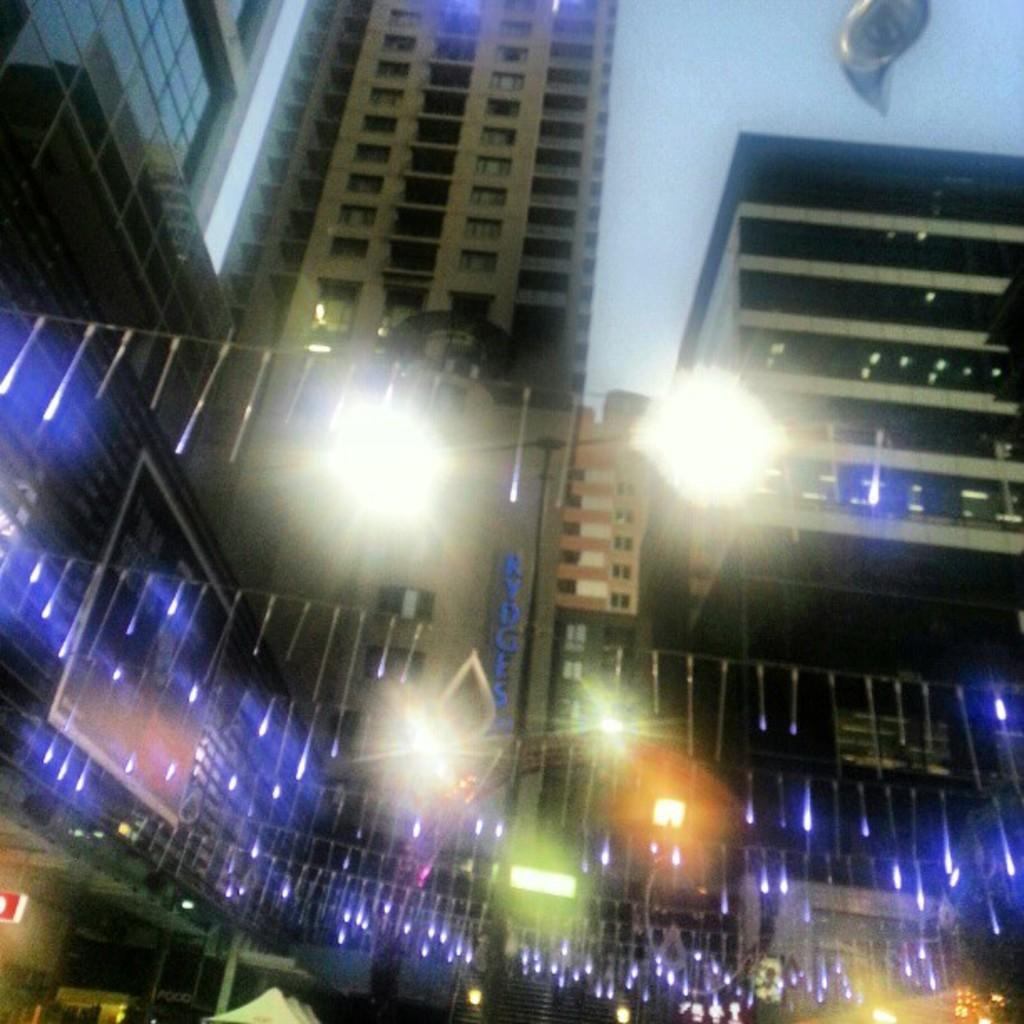In one or two sentences, can you explain what this image depicts? In this picture I can see there are few buildings and there are few lights arranged here and I can see there are few tents, banner on to left, there is a balloon at right side and the buildings have glass windows and the sky is clear. 